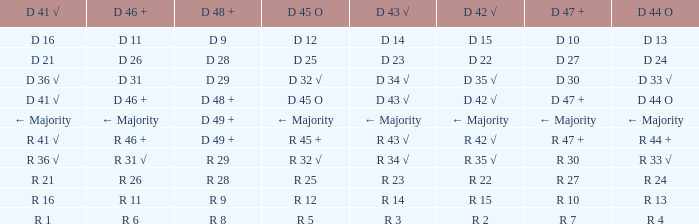What is the value of D 45 O, when the value of D 41 √ is r 41 √? R 45 +. 